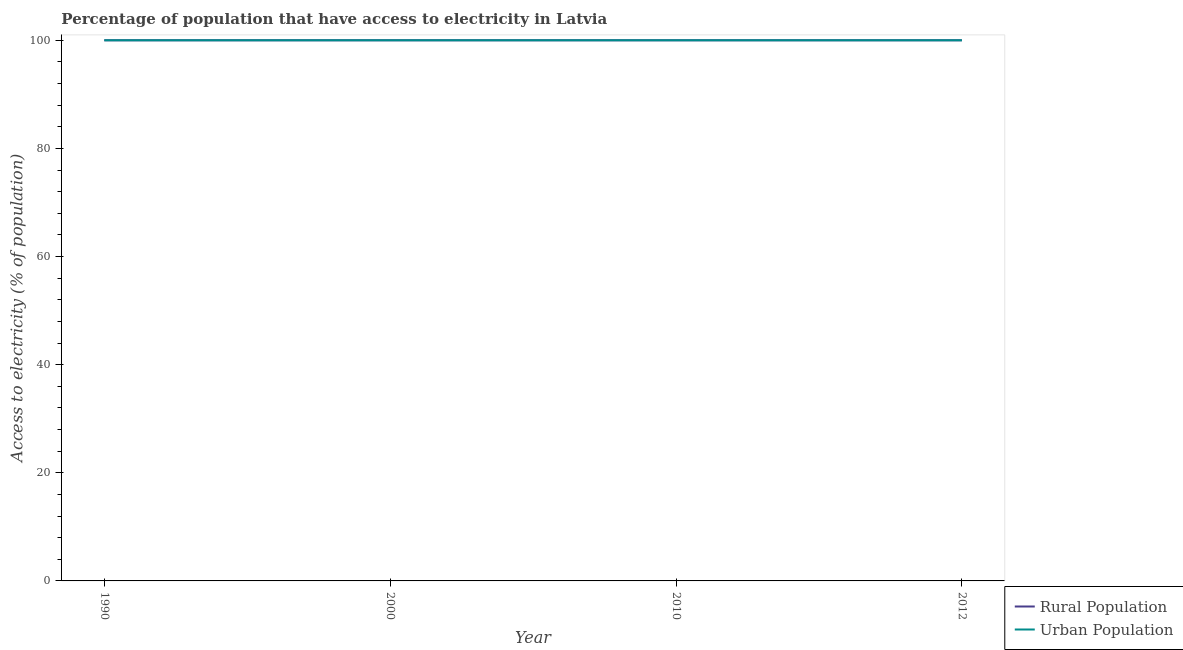How many different coloured lines are there?
Keep it short and to the point. 2. What is the percentage of urban population having access to electricity in 1990?
Ensure brevity in your answer.  100. Across all years, what is the maximum percentage of rural population having access to electricity?
Give a very brief answer. 100. Across all years, what is the minimum percentage of rural population having access to electricity?
Provide a short and direct response. 100. In which year was the percentage of rural population having access to electricity maximum?
Provide a succinct answer. 1990. In which year was the percentage of rural population having access to electricity minimum?
Ensure brevity in your answer.  1990. What is the total percentage of urban population having access to electricity in the graph?
Your response must be concise. 400. What is the difference between the percentage of urban population having access to electricity in 1990 and that in 2000?
Provide a succinct answer. 0. What is the difference between the percentage of rural population having access to electricity in 2010 and the percentage of urban population having access to electricity in 1990?
Make the answer very short. 0. In the year 2012, what is the difference between the percentage of rural population having access to electricity and percentage of urban population having access to electricity?
Provide a succinct answer. 0. In how many years, is the percentage of urban population having access to electricity greater than 24 %?
Ensure brevity in your answer.  4. What is the ratio of the percentage of urban population having access to electricity in 1990 to that in 2000?
Make the answer very short. 1. Is the difference between the percentage of urban population having access to electricity in 1990 and 2010 greater than the difference between the percentage of rural population having access to electricity in 1990 and 2010?
Give a very brief answer. No. What is the difference between the highest and the second highest percentage of rural population having access to electricity?
Your answer should be very brief. 0. What is the difference between the highest and the lowest percentage of rural population having access to electricity?
Ensure brevity in your answer.  0. Does the percentage of urban population having access to electricity monotonically increase over the years?
Your answer should be compact. No. Does the graph contain any zero values?
Your answer should be very brief. No. Does the graph contain grids?
Provide a succinct answer. No. Where does the legend appear in the graph?
Your response must be concise. Bottom right. How are the legend labels stacked?
Offer a very short reply. Vertical. What is the title of the graph?
Your answer should be very brief. Percentage of population that have access to electricity in Latvia. Does "Money lenders" appear as one of the legend labels in the graph?
Your response must be concise. No. What is the label or title of the X-axis?
Provide a succinct answer. Year. What is the label or title of the Y-axis?
Give a very brief answer. Access to electricity (% of population). What is the Access to electricity (% of population) in Rural Population in 1990?
Make the answer very short. 100. What is the Access to electricity (% of population) in Urban Population in 1990?
Offer a terse response. 100. What is the Access to electricity (% of population) of Rural Population in 2000?
Offer a terse response. 100. What is the Access to electricity (% of population) in Urban Population in 2000?
Provide a succinct answer. 100. What is the Access to electricity (% of population) of Urban Population in 2010?
Offer a terse response. 100. Across all years, what is the maximum Access to electricity (% of population) in Urban Population?
Offer a very short reply. 100. What is the total Access to electricity (% of population) of Rural Population in the graph?
Make the answer very short. 400. What is the total Access to electricity (% of population) in Urban Population in the graph?
Keep it short and to the point. 400. What is the difference between the Access to electricity (% of population) of Rural Population in 1990 and that in 2000?
Provide a short and direct response. 0. What is the difference between the Access to electricity (% of population) of Urban Population in 1990 and that in 2000?
Keep it short and to the point. 0. What is the difference between the Access to electricity (% of population) of Rural Population in 1990 and that in 2010?
Make the answer very short. 0. What is the difference between the Access to electricity (% of population) of Urban Population in 2000 and that in 2010?
Make the answer very short. 0. What is the difference between the Access to electricity (% of population) in Rural Population in 2000 and that in 2012?
Your answer should be very brief. 0. What is the difference between the Access to electricity (% of population) in Urban Population in 2000 and that in 2012?
Your response must be concise. 0. What is the difference between the Access to electricity (% of population) of Rural Population in 2010 and that in 2012?
Offer a very short reply. 0. What is the difference between the Access to electricity (% of population) in Rural Population in 2000 and the Access to electricity (% of population) in Urban Population in 2010?
Give a very brief answer. 0. What is the average Access to electricity (% of population) in Urban Population per year?
Give a very brief answer. 100. In the year 2012, what is the difference between the Access to electricity (% of population) in Rural Population and Access to electricity (% of population) in Urban Population?
Your answer should be very brief. 0. What is the ratio of the Access to electricity (% of population) in Urban Population in 1990 to that in 2000?
Keep it short and to the point. 1. What is the ratio of the Access to electricity (% of population) of Urban Population in 1990 to that in 2010?
Your response must be concise. 1. What is the ratio of the Access to electricity (% of population) in Urban Population in 2000 to that in 2012?
Keep it short and to the point. 1. What is the ratio of the Access to electricity (% of population) of Rural Population in 2010 to that in 2012?
Offer a very short reply. 1. What is the ratio of the Access to electricity (% of population) of Urban Population in 2010 to that in 2012?
Offer a very short reply. 1. What is the difference between the highest and the second highest Access to electricity (% of population) of Rural Population?
Provide a succinct answer. 0. What is the difference between the highest and the lowest Access to electricity (% of population) in Rural Population?
Your answer should be very brief. 0. 